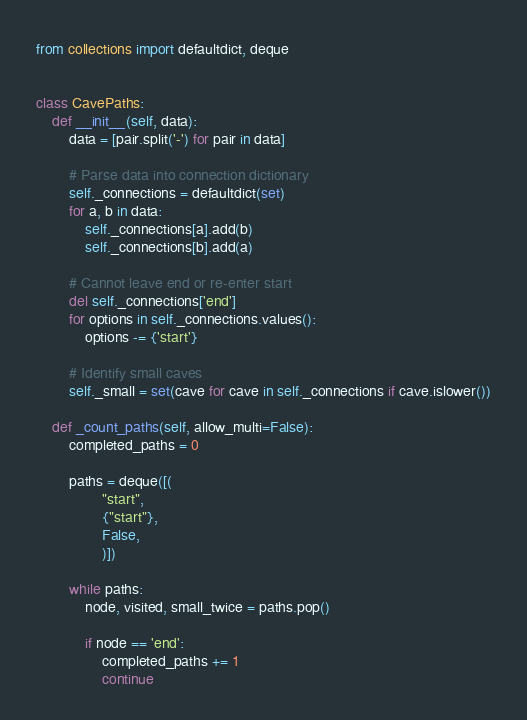<code> <loc_0><loc_0><loc_500><loc_500><_Python_>from collections import defaultdict, deque


class CavePaths:
    def __init__(self, data):
        data = [pair.split('-') for pair in data]
        
        # Parse data into connection dictionary
        self._connections = defaultdict(set)
        for a, b in data:
            self._connections[a].add(b)
            self._connections[b].add(a)
        
        # Cannot leave end or re-enter start
        del self._connections['end']
        for options in self._connections.values():
            options -= {'start'}
        
        # Identify small caves
        self._small = set(cave for cave in self._connections if cave.islower())
    
    def _count_paths(self, allow_multi=False):
        completed_paths = 0
        
        paths = deque([(
                "start",
                {"start"},
                False,
                )])
        
        while paths:
            node, visited, small_twice = paths.pop()
            
            if node == 'end':
                completed_paths += 1
                continue
</code> 